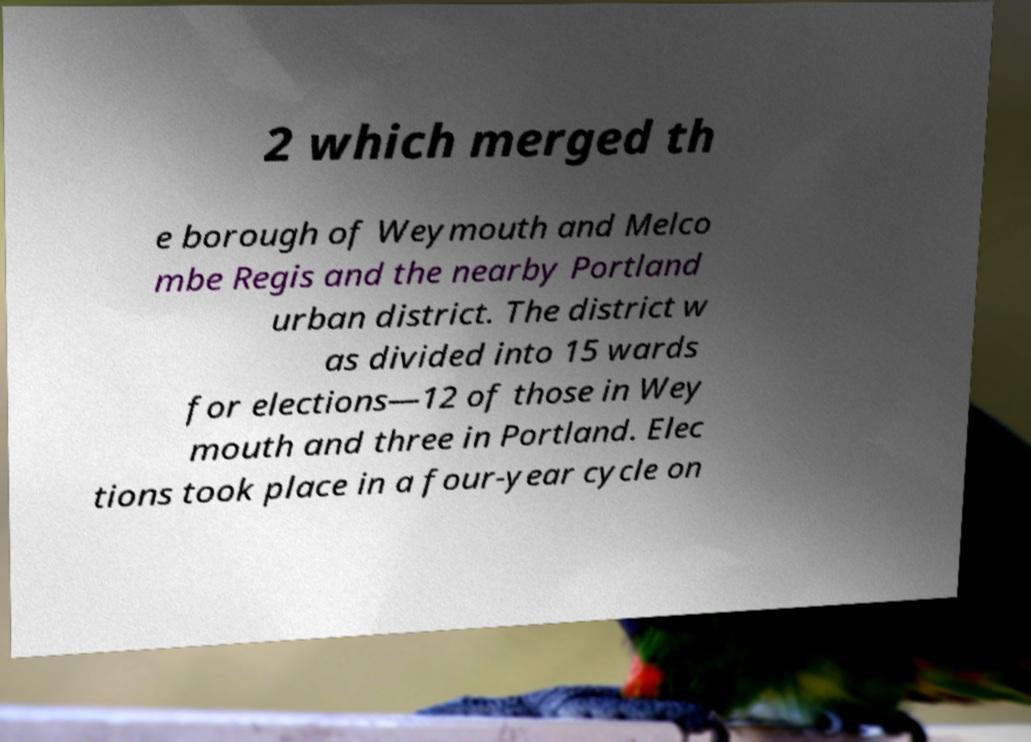What messages or text are displayed in this image? I need them in a readable, typed format. 2 which merged th e borough of Weymouth and Melco mbe Regis and the nearby Portland urban district. The district w as divided into 15 wards for elections—12 of those in Wey mouth and three in Portland. Elec tions took place in a four-year cycle on 